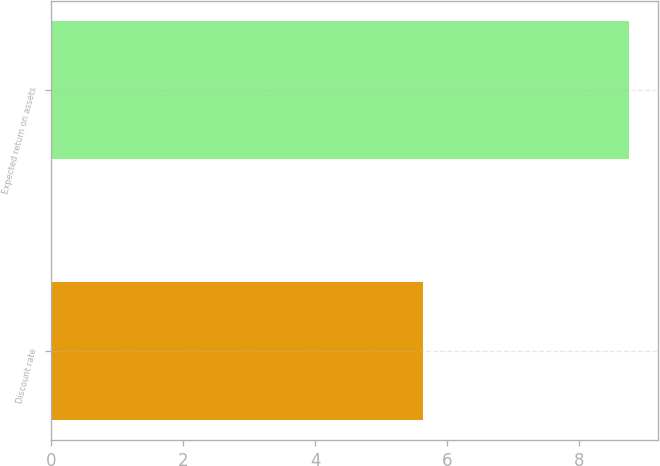<chart> <loc_0><loc_0><loc_500><loc_500><bar_chart><fcel>Discount rate<fcel>Expected return on assets<nl><fcel>5.64<fcel>8.75<nl></chart> 